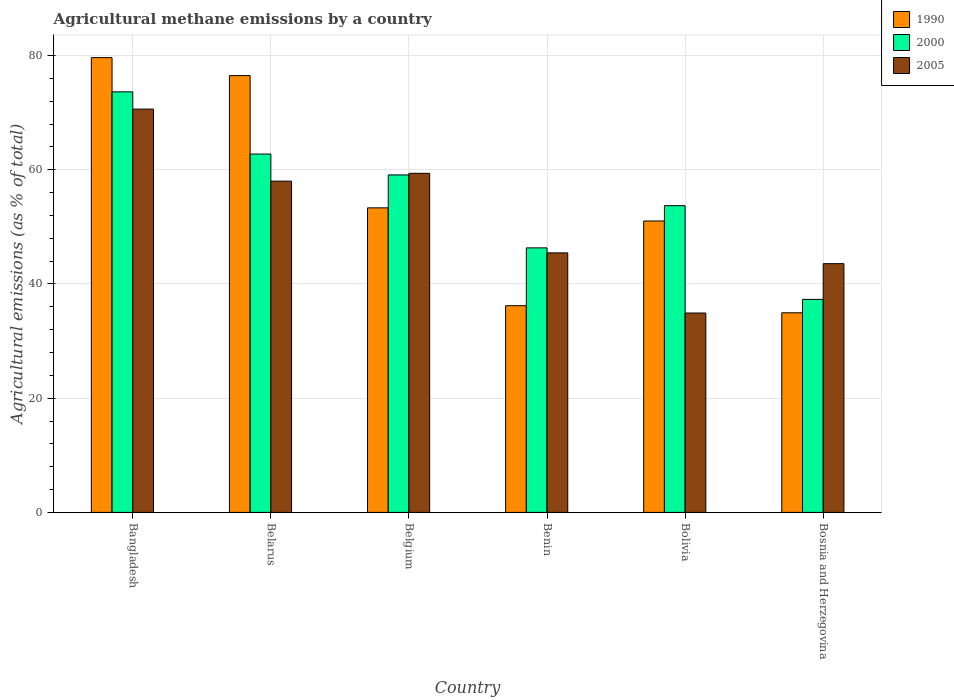How many groups of bars are there?
Keep it short and to the point. 6. How many bars are there on the 6th tick from the right?
Make the answer very short. 3. What is the label of the 2nd group of bars from the left?
Offer a terse response. Belarus. In how many cases, is the number of bars for a given country not equal to the number of legend labels?
Offer a terse response. 0. What is the amount of agricultural methane emitted in 2005 in Bolivia?
Ensure brevity in your answer.  34.92. Across all countries, what is the maximum amount of agricultural methane emitted in 2005?
Your answer should be very brief. 70.62. Across all countries, what is the minimum amount of agricultural methane emitted in 2005?
Your response must be concise. 34.92. What is the total amount of agricultural methane emitted in 1990 in the graph?
Keep it short and to the point. 331.63. What is the difference between the amount of agricultural methane emitted in 1990 in Bolivia and that in Bosnia and Herzegovina?
Ensure brevity in your answer.  16.08. What is the difference between the amount of agricultural methane emitted in 2000 in Bolivia and the amount of agricultural methane emitted in 2005 in Benin?
Offer a very short reply. 8.27. What is the average amount of agricultural methane emitted in 1990 per country?
Provide a succinct answer. 55.27. What is the difference between the amount of agricultural methane emitted of/in 2000 and amount of agricultural methane emitted of/in 1990 in Bangladesh?
Offer a terse response. -6. What is the ratio of the amount of agricultural methane emitted in 2005 in Benin to that in Bosnia and Herzegovina?
Provide a succinct answer. 1.04. Is the amount of agricultural methane emitted in 1990 in Bolivia less than that in Bosnia and Herzegovina?
Keep it short and to the point. No. Is the difference between the amount of agricultural methane emitted in 2000 in Belarus and Benin greater than the difference between the amount of agricultural methane emitted in 1990 in Belarus and Benin?
Offer a terse response. No. What is the difference between the highest and the second highest amount of agricultural methane emitted in 2005?
Provide a succinct answer. -1.37. What is the difference between the highest and the lowest amount of agricultural methane emitted in 1990?
Your answer should be compact. 44.69. Is the sum of the amount of agricultural methane emitted in 2000 in Belarus and Benin greater than the maximum amount of agricultural methane emitted in 1990 across all countries?
Offer a terse response. Yes. What does the 2nd bar from the left in Belarus represents?
Make the answer very short. 2000. Is it the case that in every country, the sum of the amount of agricultural methane emitted in 2005 and amount of agricultural methane emitted in 1990 is greater than the amount of agricultural methane emitted in 2000?
Your answer should be compact. Yes. How many countries are there in the graph?
Ensure brevity in your answer.  6. Does the graph contain grids?
Keep it short and to the point. Yes. Where does the legend appear in the graph?
Keep it short and to the point. Top right. How many legend labels are there?
Ensure brevity in your answer.  3. How are the legend labels stacked?
Ensure brevity in your answer.  Vertical. What is the title of the graph?
Ensure brevity in your answer.  Agricultural methane emissions by a country. What is the label or title of the Y-axis?
Provide a short and direct response. Agricultural emissions (as % of total). What is the Agricultural emissions (as % of total) in 1990 in Bangladesh?
Offer a terse response. 79.64. What is the Agricultural emissions (as % of total) of 2000 in Bangladesh?
Provide a succinct answer. 73.64. What is the Agricultural emissions (as % of total) in 2005 in Bangladesh?
Keep it short and to the point. 70.62. What is the Agricultural emissions (as % of total) of 1990 in Belarus?
Offer a terse response. 76.49. What is the Agricultural emissions (as % of total) in 2000 in Belarus?
Ensure brevity in your answer.  62.75. What is the Agricultural emissions (as % of total) in 2005 in Belarus?
Make the answer very short. 58.01. What is the Agricultural emissions (as % of total) in 1990 in Belgium?
Your answer should be very brief. 53.33. What is the Agricultural emissions (as % of total) in 2000 in Belgium?
Offer a very short reply. 59.1. What is the Agricultural emissions (as % of total) in 2005 in Belgium?
Your answer should be compact. 59.37. What is the Agricultural emissions (as % of total) in 1990 in Benin?
Provide a short and direct response. 36.19. What is the Agricultural emissions (as % of total) of 2000 in Benin?
Provide a short and direct response. 46.32. What is the Agricultural emissions (as % of total) of 2005 in Benin?
Make the answer very short. 45.44. What is the Agricultural emissions (as % of total) in 1990 in Bolivia?
Ensure brevity in your answer.  51.03. What is the Agricultural emissions (as % of total) of 2000 in Bolivia?
Give a very brief answer. 53.71. What is the Agricultural emissions (as % of total) of 2005 in Bolivia?
Give a very brief answer. 34.92. What is the Agricultural emissions (as % of total) of 1990 in Bosnia and Herzegovina?
Offer a very short reply. 34.95. What is the Agricultural emissions (as % of total) of 2000 in Bosnia and Herzegovina?
Provide a short and direct response. 37.3. What is the Agricultural emissions (as % of total) of 2005 in Bosnia and Herzegovina?
Provide a succinct answer. 43.56. Across all countries, what is the maximum Agricultural emissions (as % of total) in 1990?
Offer a very short reply. 79.64. Across all countries, what is the maximum Agricultural emissions (as % of total) of 2000?
Provide a succinct answer. 73.64. Across all countries, what is the maximum Agricultural emissions (as % of total) in 2005?
Offer a very short reply. 70.62. Across all countries, what is the minimum Agricultural emissions (as % of total) of 1990?
Provide a succinct answer. 34.95. Across all countries, what is the minimum Agricultural emissions (as % of total) in 2000?
Your answer should be very brief. 37.3. Across all countries, what is the minimum Agricultural emissions (as % of total) in 2005?
Keep it short and to the point. 34.92. What is the total Agricultural emissions (as % of total) in 1990 in the graph?
Make the answer very short. 331.63. What is the total Agricultural emissions (as % of total) of 2000 in the graph?
Give a very brief answer. 332.83. What is the total Agricultural emissions (as % of total) of 2005 in the graph?
Give a very brief answer. 311.92. What is the difference between the Agricultural emissions (as % of total) in 1990 in Bangladesh and that in Belarus?
Make the answer very short. 3.15. What is the difference between the Agricultural emissions (as % of total) in 2000 in Bangladesh and that in Belarus?
Provide a short and direct response. 10.89. What is the difference between the Agricultural emissions (as % of total) in 2005 in Bangladesh and that in Belarus?
Your answer should be compact. 12.62. What is the difference between the Agricultural emissions (as % of total) in 1990 in Bangladesh and that in Belgium?
Your answer should be very brief. 26.31. What is the difference between the Agricultural emissions (as % of total) in 2000 in Bangladesh and that in Belgium?
Your response must be concise. 14.55. What is the difference between the Agricultural emissions (as % of total) in 2005 in Bangladesh and that in Belgium?
Your answer should be very brief. 11.25. What is the difference between the Agricultural emissions (as % of total) of 1990 in Bangladesh and that in Benin?
Give a very brief answer. 43.44. What is the difference between the Agricultural emissions (as % of total) in 2000 in Bangladesh and that in Benin?
Make the answer very short. 27.32. What is the difference between the Agricultural emissions (as % of total) in 2005 in Bangladesh and that in Benin?
Offer a terse response. 25.18. What is the difference between the Agricultural emissions (as % of total) of 1990 in Bangladesh and that in Bolivia?
Provide a succinct answer. 28.61. What is the difference between the Agricultural emissions (as % of total) in 2000 in Bangladesh and that in Bolivia?
Keep it short and to the point. 19.93. What is the difference between the Agricultural emissions (as % of total) in 2005 in Bangladesh and that in Bolivia?
Give a very brief answer. 35.71. What is the difference between the Agricultural emissions (as % of total) in 1990 in Bangladesh and that in Bosnia and Herzegovina?
Keep it short and to the point. 44.69. What is the difference between the Agricultural emissions (as % of total) of 2000 in Bangladesh and that in Bosnia and Herzegovina?
Keep it short and to the point. 36.34. What is the difference between the Agricultural emissions (as % of total) in 2005 in Bangladesh and that in Bosnia and Herzegovina?
Make the answer very short. 27.06. What is the difference between the Agricultural emissions (as % of total) in 1990 in Belarus and that in Belgium?
Your answer should be very brief. 23.16. What is the difference between the Agricultural emissions (as % of total) in 2000 in Belarus and that in Belgium?
Give a very brief answer. 3.65. What is the difference between the Agricultural emissions (as % of total) in 2005 in Belarus and that in Belgium?
Offer a very short reply. -1.37. What is the difference between the Agricultural emissions (as % of total) of 1990 in Belarus and that in Benin?
Your answer should be very brief. 40.29. What is the difference between the Agricultural emissions (as % of total) in 2000 in Belarus and that in Benin?
Give a very brief answer. 16.43. What is the difference between the Agricultural emissions (as % of total) in 2005 in Belarus and that in Benin?
Make the answer very short. 12.56. What is the difference between the Agricultural emissions (as % of total) of 1990 in Belarus and that in Bolivia?
Your answer should be compact. 25.46. What is the difference between the Agricultural emissions (as % of total) of 2000 in Belarus and that in Bolivia?
Ensure brevity in your answer.  9.04. What is the difference between the Agricultural emissions (as % of total) of 2005 in Belarus and that in Bolivia?
Give a very brief answer. 23.09. What is the difference between the Agricultural emissions (as % of total) in 1990 in Belarus and that in Bosnia and Herzegovina?
Your answer should be compact. 41.53. What is the difference between the Agricultural emissions (as % of total) of 2000 in Belarus and that in Bosnia and Herzegovina?
Offer a terse response. 25.45. What is the difference between the Agricultural emissions (as % of total) in 2005 in Belarus and that in Bosnia and Herzegovina?
Provide a short and direct response. 14.44. What is the difference between the Agricultural emissions (as % of total) of 1990 in Belgium and that in Benin?
Offer a very short reply. 17.14. What is the difference between the Agricultural emissions (as % of total) of 2000 in Belgium and that in Benin?
Your answer should be compact. 12.77. What is the difference between the Agricultural emissions (as % of total) of 2005 in Belgium and that in Benin?
Your answer should be very brief. 13.93. What is the difference between the Agricultural emissions (as % of total) of 1990 in Belgium and that in Bolivia?
Offer a terse response. 2.3. What is the difference between the Agricultural emissions (as % of total) in 2000 in Belgium and that in Bolivia?
Provide a short and direct response. 5.38. What is the difference between the Agricultural emissions (as % of total) of 2005 in Belgium and that in Bolivia?
Your answer should be very brief. 24.46. What is the difference between the Agricultural emissions (as % of total) of 1990 in Belgium and that in Bosnia and Herzegovina?
Your answer should be very brief. 18.38. What is the difference between the Agricultural emissions (as % of total) of 2000 in Belgium and that in Bosnia and Herzegovina?
Ensure brevity in your answer.  21.79. What is the difference between the Agricultural emissions (as % of total) of 2005 in Belgium and that in Bosnia and Herzegovina?
Offer a very short reply. 15.81. What is the difference between the Agricultural emissions (as % of total) in 1990 in Benin and that in Bolivia?
Keep it short and to the point. -14.83. What is the difference between the Agricultural emissions (as % of total) in 2000 in Benin and that in Bolivia?
Give a very brief answer. -7.39. What is the difference between the Agricultural emissions (as % of total) in 2005 in Benin and that in Bolivia?
Provide a short and direct response. 10.53. What is the difference between the Agricultural emissions (as % of total) in 1990 in Benin and that in Bosnia and Herzegovina?
Offer a very short reply. 1.24. What is the difference between the Agricultural emissions (as % of total) in 2000 in Benin and that in Bosnia and Herzegovina?
Provide a succinct answer. 9.02. What is the difference between the Agricultural emissions (as % of total) in 2005 in Benin and that in Bosnia and Herzegovina?
Ensure brevity in your answer.  1.88. What is the difference between the Agricultural emissions (as % of total) in 1990 in Bolivia and that in Bosnia and Herzegovina?
Your response must be concise. 16.08. What is the difference between the Agricultural emissions (as % of total) in 2000 in Bolivia and that in Bosnia and Herzegovina?
Ensure brevity in your answer.  16.41. What is the difference between the Agricultural emissions (as % of total) of 2005 in Bolivia and that in Bosnia and Herzegovina?
Offer a terse response. -8.64. What is the difference between the Agricultural emissions (as % of total) of 1990 in Bangladesh and the Agricultural emissions (as % of total) of 2000 in Belarus?
Your answer should be compact. 16.89. What is the difference between the Agricultural emissions (as % of total) of 1990 in Bangladesh and the Agricultural emissions (as % of total) of 2005 in Belarus?
Make the answer very short. 21.63. What is the difference between the Agricultural emissions (as % of total) of 2000 in Bangladesh and the Agricultural emissions (as % of total) of 2005 in Belarus?
Your response must be concise. 15.64. What is the difference between the Agricultural emissions (as % of total) of 1990 in Bangladesh and the Agricultural emissions (as % of total) of 2000 in Belgium?
Your answer should be compact. 20.54. What is the difference between the Agricultural emissions (as % of total) in 1990 in Bangladesh and the Agricultural emissions (as % of total) in 2005 in Belgium?
Provide a succinct answer. 20.27. What is the difference between the Agricultural emissions (as % of total) in 2000 in Bangladesh and the Agricultural emissions (as % of total) in 2005 in Belgium?
Your answer should be compact. 14.27. What is the difference between the Agricultural emissions (as % of total) in 1990 in Bangladesh and the Agricultural emissions (as % of total) in 2000 in Benin?
Make the answer very short. 33.32. What is the difference between the Agricultural emissions (as % of total) in 1990 in Bangladesh and the Agricultural emissions (as % of total) in 2005 in Benin?
Your answer should be very brief. 34.2. What is the difference between the Agricultural emissions (as % of total) of 2000 in Bangladesh and the Agricultural emissions (as % of total) of 2005 in Benin?
Provide a short and direct response. 28.2. What is the difference between the Agricultural emissions (as % of total) in 1990 in Bangladesh and the Agricultural emissions (as % of total) in 2000 in Bolivia?
Provide a short and direct response. 25.92. What is the difference between the Agricultural emissions (as % of total) of 1990 in Bangladesh and the Agricultural emissions (as % of total) of 2005 in Bolivia?
Your answer should be compact. 44.72. What is the difference between the Agricultural emissions (as % of total) in 2000 in Bangladesh and the Agricultural emissions (as % of total) in 2005 in Bolivia?
Provide a succinct answer. 38.73. What is the difference between the Agricultural emissions (as % of total) in 1990 in Bangladesh and the Agricultural emissions (as % of total) in 2000 in Bosnia and Herzegovina?
Your answer should be very brief. 42.34. What is the difference between the Agricultural emissions (as % of total) in 1990 in Bangladesh and the Agricultural emissions (as % of total) in 2005 in Bosnia and Herzegovina?
Your answer should be very brief. 36.08. What is the difference between the Agricultural emissions (as % of total) of 2000 in Bangladesh and the Agricultural emissions (as % of total) of 2005 in Bosnia and Herzegovina?
Offer a very short reply. 30.08. What is the difference between the Agricultural emissions (as % of total) of 1990 in Belarus and the Agricultural emissions (as % of total) of 2000 in Belgium?
Your answer should be very brief. 17.39. What is the difference between the Agricultural emissions (as % of total) in 1990 in Belarus and the Agricultural emissions (as % of total) in 2005 in Belgium?
Give a very brief answer. 17.11. What is the difference between the Agricultural emissions (as % of total) of 2000 in Belarus and the Agricultural emissions (as % of total) of 2005 in Belgium?
Offer a terse response. 3.38. What is the difference between the Agricultural emissions (as % of total) of 1990 in Belarus and the Agricultural emissions (as % of total) of 2000 in Benin?
Your answer should be very brief. 30.16. What is the difference between the Agricultural emissions (as % of total) in 1990 in Belarus and the Agricultural emissions (as % of total) in 2005 in Benin?
Your answer should be compact. 31.04. What is the difference between the Agricultural emissions (as % of total) of 2000 in Belarus and the Agricultural emissions (as % of total) of 2005 in Benin?
Give a very brief answer. 17.31. What is the difference between the Agricultural emissions (as % of total) of 1990 in Belarus and the Agricultural emissions (as % of total) of 2000 in Bolivia?
Offer a very short reply. 22.77. What is the difference between the Agricultural emissions (as % of total) of 1990 in Belarus and the Agricultural emissions (as % of total) of 2005 in Bolivia?
Offer a terse response. 41.57. What is the difference between the Agricultural emissions (as % of total) of 2000 in Belarus and the Agricultural emissions (as % of total) of 2005 in Bolivia?
Your answer should be very brief. 27.83. What is the difference between the Agricultural emissions (as % of total) of 1990 in Belarus and the Agricultural emissions (as % of total) of 2000 in Bosnia and Herzegovina?
Offer a terse response. 39.19. What is the difference between the Agricultural emissions (as % of total) in 1990 in Belarus and the Agricultural emissions (as % of total) in 2005 in Bosnia and Herzegovina?
Your response must be concise. 32.93. What is the difference between the Agricultural emissions (as % of total) in 2000 in Belarus and the Agricultural emissions (as % of total) in 2005 in Bosnia and Herzegovina?
Your response must be concise. 19.19. What is the difference between the Agricultural emissions (as % of total) in 1990 in Belgium and the Agricultural emissions (as % of total) in 2000 in Benin?
Ensure brevity in your answer.  7.01. What is the difference between the Agricultural emissions (as % of total) of 1990 in Belgium and the Agricultural emissions (as % of total) of 2005 in Benin?
Your response must be concise. 7.89. What is the difference between the Agricultural emissions (as % of total) in 2000 in Belgium and the Agricultural emissions (as % of total) in 2005 in Benin?
Your answer should be very brief. 13.65. What is the difference between the Agricultural emissions (as % of total) in 1990 in Belgium and the Agricultural emissions (as % of total) in 2000 in Bolivia?
Give a very brief answer. -0.38. What is the difference between the Agricultural emissions (as % of total) in 1990 in Belgium and the Agricultural emissions (as % of total) in 2005 in Bolivia?
Offer a very short reply. 18.41. What is the difference between the Agricultural emissions (as % of total) of 2000 in Belgium and the Agricultural emissions (as % of total) of 2005 in Bolivia?
Offer a terse response. 24.18. What is the difference between the Agricultural emissions (as % of total) of 1990 in Belgium and the Agricultural emissions (as % of total) of 2000 in Bosnia and Herzegovina?
Ensure brevity in your answer.  16.03. What is the difference between the Agricultural emissions (as % of total) of 1990 in Belgium and the Agricultural emissions (as % of total) of 2005 in Bosnia and Herzegovina?
Provide a succinct answer. 9.77. What is the difference between the Agricultural emissions (as % of total) in 2000 in Belgium and the Agricultural emissions (as % of total) in 2005 in Bosnia and Herzegovina?
Provide a succinct answer. 15.54. What is the difference between the Agricultural emissions (as % of total) of 1990 in Benin and the Agricultural emissions (as % of total) of 2000 in Bolivia?
Provide a short and direct response. -17.52. What is the difference between the Agricultural emissions (as % of total) of 1990 in Benin and the Agricultural emissions (as % of total) of 2005 in Bolivia?
Provide a short and direct response. 1.28. What is the difference between the Agricultural emissions (as % of total) of 2000 in Benin and the Agricultural emissions (as % of total) of 2005 in Bolivia?
Keep it short and to the point. 11.41. What is the difference between the Agricultural emissions (as % of total) in 1990 in Benin and the Agricultural emissions (as % of total) in 2000 in Bosnia and Herzegovina?
Offer a terse response. -1.11. What is the difference between the Agricultural emissions (as % of total) in 1990 in Benin and the Agricultural emissions (as % of total) in 2005 in Bosnia and Herzegovina?
Offer a very short reply. -7.37. What is the difference between the Agricultural emissions (as % of total) of 2000 in Benin and the Agricultural emissions (as % of total) of 2005 in Bosnia and Herzegovina?
Offer a very short reply. 2.76. What is the difference between the Agricultural emissions (as % of total) in 1990 in Bolivia and the Agricultural emissions (as % of total) in 2000 in Bosnia and Herzegovina?
Your answer should be very brief. 13.73. What is the difference between the Agricultural emissions (as % of total) of 1990 in Bolivia and the Agricultural emissions (as % of total) of 2005 in Bosnia and Herzegovina?
Make the answer very short. 7.47. What is the difference between the Agricultural emissions (as % of total) in 2000 in Bolivia and the Agricultural emissions (as % of total) in 2005 in Bosnia and Herzegovina?
Ensure brevity in your answer.  10.15. What is the average Agricultural emissions (as % of total) in 1990 per country?
Your answer should be compact. 55.27. What is the average Agricultural emissions (as % of total) in 2000 per country?
Your answer should be very brief. 55.47. What is the average Agricultural emissions (as % of total) in 2005 per country?
Ensure brevity in your answer.  51.99. What is the difference between the Agricultural emissions (as % of total) in 1990 and Agricultural emissions (as % of total) in 2000 in Bangladesh?
Your response must be concise. 6. What is the difference between the Agricultural emissions (as % of total) in 1990 and Agricultural emissions (as % of total) in 2005 in Bangladesh?
Keep it short and to the point. 9.02. What is the difference between the Agricultural emissions (as % of total) in 2000 and Agricultural emissions (as % of total) in 2005 in Bangladesh?
Offer a terse response. 3.02. What is the difference between the Agricultural emissions (as % of total) in 1990 and Agricultural emissions (as % of total) in 2000 in Belarus?
Your response must be concise. 13.74. What is the difference between the Agricultural emissions (as % of total) in 1990 and Agricultural emissions (as % of total) in 2005 in Belarus?
Keep it short and to the point. 18.48. What is the difference between the Agricultural emissions (as % of total) of 2000 and Agricultural emissions (as % of total) of 2005 in Belarus?
Your answer should be compact. 4.74. What is the difference between the Agricultural emissions (as % of total) of 1990 and Agricultural emissions (as % of total) of 2000 in Belgium?
Keep it short and to the point. -5.77. What is the difference between the Agricultural emissions (as % of total) in 1990 and Agricultural emissions (as % of total) in 2005 in Belgium?
Provide a short and direct response. -6.04. What is the difference between the Agricultural emissions (as % of total) in 2000 and Agricultural emissions (as % of total) in 2005 in Belgium?
Your response must be concise. -0.28. What is the difference between the Agricultural emissions (as % of total) in 1990 and Agricultural emissions (as % of total) in 2000 in Benin?
Offer a terse response. -10.13. What is the difference between the Agricultural emissions (as % of total) of 1990 and Agricultural emissions (as % of total) of 2005 in Benin?
Offer a very short reply. -9.25. What is the difference between the Agricultural emissions (as % of total) in 2000 and Agricultural emissions (as % of total) in 2005 in Benin?
Your answer should be very brief. 0.88. What is the difference between the Agricultural emissions (as % of total) in 1990 and Agricultural emissions (as % of total) in 2000 in Bolivia?
Provide a short and direct response. -2.69. What is the difference between the Agricultural emissions (as % of total) in 1990 and Agricultural emissions (as % of total) in 2005 in Bolivia?
Provide a short and direct response. 16.11. What is the difference between the Agricultural emissions (as % of total) of 2000 and Agricultural emissions (as % of total) of 2005 in Bolivia?
Your answer should be very brief. 18.8. What is the difference between the Agricultural emissions (as % of total) in 1990 and Agricultural emissions (as % of total) in 2000 in Bosnia and Herzegovina?
Keep it short and to the point. -2.35. What is the difference between the Agricultural emissions (as % of total) of 1990 and Agricultural emissions (as % of total) of 2005 in Bosnia and Herzegovina?
Your answer should be compact. -8.61. What is the difference between the Agricultural emissions (as % of total) in 2000 and Agricultural emissions (as % of total) in 2005 in Bosnia and Herzegovina?
Your answer should be compact. -6.26. What is the ratio of the Agricultural emissions (as % of total) in 1990 in Bangladesh to that in Belarus?
Offer a terse response. 1.04. What is the ratio of the Agricultural emissions (as % of total) in 2000 in Bangladesh to that in Belarus?
Offer a terse response. 1.17. What is the ratio of the Agricultural emissions (as % of total) of 2005 in Bangladesh to that in Belarus?
Your answer should be very brief. 1.22. What is the ratio of the Agricultural emissions (as % of total) of 1990 in Bangladesh to that in Belgium?
Keep it short and to the point. 1.49. What is the ratio of the Agricultural emissions (as % of total) of 2000 in Bangladesh to that in Belgium?
Make the answer very short. 1.25. What is the ratio of the Agricultural emissions (as % of total) in 2005 in Bangladesh to that in Belgium?
Make the answer very short. 1.19. What is the ratio of the Agricultural emissions (as % of total) of 1990 in Bangladesh to that in Benin?
Provide a succinct answer. 2.2. What is the ratio of the Agricultural emissions (as % of total) of 2000 in Bangladesh to that in Benin?
Provide a short and direct response. 1.59. What is the ratio of the Agricultural emissions (as % of total) in 2005 in Bangladesh to that in Benin?
Give a very brief answer. 1.55. What is the ratio of the Agricultural emissions (as % of total) in 1990 in Bangladesh to that in Bolivia?
Your answer should be very brief. 1.56. What is the ratio of the Agricultural emissions (as % of total) of 2000 in Bangladesh to that in Bolivia?
Provide a succinct answer. 1.37. What is the ratio of the Agricultural emissions (as % of total) in 2005 in Bangladesh to that in Bolivia?
Provide a succinct answer. 2.02. What is the ratio of the Agricultural emissions (as % of total) in 1990 in Bangladesh to that in Bosnia and Herzegovina?
Offer a very short reply. 2.28. What is the ratio of the Agricultural emissions (as % of total) in 2000 in Bangladesh to that in Bosnia and Herzegovina?
Give a very brief answer. 1.97. What is the ratio of the Agricultural emissions (as % of total) of 2005 in Bangladesh to that in Bosnia and Herzegovina?
Offer a terse response. 1.62. What is the ratio of the Agricultural emissions (as % of total) of 1990 in Belarus to that in Belgium?
Make the answer very short. 1.43. What is the ratio of the Agricultural emissions (as % of total) of 2000 in Belarus to that in Belgium?
Give a very brief answer. 1.06. What is the ratio of the Agricultural emissions (as % of total) in 1990 in Belarus to that in Benin?
Your answer should be compact. 2.11. What is the ratio of the Agricultural emissions (as % of total) of 2000 in Belarus to that in Benin?
Your response must be concise. 1.35. What is the ratio of the Agricultural emissions (as % of total) in 2005 in Belarus to that in Benin?
Provide a succinct answer. 1.28. What is the ratio of the Agricultural emissions (as % of total) of 1990 in Belarus to that in Bolivia?
Offer a very short reply. 1.5. What is the ratio of the Agricultural emissions (as % of total) of 2000 in Belarus to that in Bolivia?
Give a very brief answer. 1.17. What is the ratio of the Agricultural emissions (as % of total) of 2005 in Belarus to that in Bolivia?
Offer a very short reply. 1.66. What is the ratio of the Agricultural emissions (as % of total) of 1990 in Belarus to that in Bosnia and Herzegovina?
Your answer should be compact. 2.19. What is the ratio of the Agricultural emissions (as % of total) in 2000 in Belarus to that in Bosnia and Herzegovina?
Ensure brevity in your answer.  1.68. What is the ratio of the Agricultural emissions (as % of total) in 2005 in Belarus to that in Bosnia and Herzegovina?
Provide a short and direct response. 1.33. What is the ratio of the Agricultural emissions (as % of total) of 1990 in Belgium to that in Benin?
Your response must be concise. 1.47. What is the ratio of the Agricultural emissions (as % of total) of 2000 in Belgium to that in Benin?
Provide a short and direct response. 1.28. What is the ratio of the Agricultural emissions (as % of total) in 2005 in Belgium to that in Benin?
Make the answer very short. 1.31. What is the ratio of the Agricultural emissions (as % of total) of 1990 in Belgium to that in Bolivia?
Make the answer very short. 1.05. What is the ratio of the Agricultural emissions (as % of total) in 2000 in Belgium to that in Bolivia?
Offer a very short reply. 1.1. What is the ratio of the Agricultural emissions (as % of total) in 2005 in Belgium to that in Bolivia?
Your answer should be compact. 1.7. What is the ratio of the Agricultural emissions (as % of total) of 1990 in Belgium to that in Bosnia and Herzegovina?
Offer a very short reply. 1.53. What is the ratio of the Agricultural emissions (as % of total) of 2000 in Belgium to that in Bosnia and Herzegovina?
Keep it short and to the point. 1.58. What is the ratio of the Agricultural emissions (as % of total) in 2005 in Belgium to that in Bosnia and Herzegovina?
Your response must be concise. 1.36. What is the ratio of the Agricultural emissions (as % of total) of 1990 in Benin to that in Bolivia?
Your answer should be very brief. 0.71. What is the ratio of the Agricultural emissions (as % of total) of 2000 in Benin to that in Bolivia?
Offer a very short reply. 0.86. What is the ratio of the Agricultural emissions (as % of total) of 2005 in Benin to that in Bolivia?
Provide a short and direct response. 1.3. What is the ratio of the Agricultural emissions (as % of total) of 1990 in Benin to that in Bosnia and Herzegovina?
Keep it short and to the point. 1.04. What is the ratio of the Agricultural emissions (as % of total) of 2000 in Benin to that in Bosnia and Herzegovina?
Offer a terse response. 1.24. What is the ratio of the Agricultural emissions (as % of total) of 2005 in Benin to that in Bosnia and Herzegovina?
Make the answer very short. 1.04. What is the ratio of the Agricultural emissions (as % of total) of 1990 in Bolivia to that in Bosnia and Herzegovina?
Offer a very short reply. 1.46. What is the ratio of the Agricultural emissions (as % of total) of 2000 in Bolivia to that in Bosnia and Herzegovina?
Provide a succinct answer. 1.44. What is the ratio of the Agricultural emissions (as % of total) of 2005 in Bolivia to that in Bosnia and Herzegovina?
Your answer should be very brief. 0.8. What is the difference between the highest and the second highest Agricultural emissions (as % of total) of 1990?
Provide a succinct answer. 3.15. What is the difference between the highest and the second highest Agricultural emissions (as % of total) of 2000?
Your response must be concise. 10.89. What is the difference between the highest and the second highest Agricultural emissions (as % of total) of 2005?
Make the answer very short. 11.25. What is the difference between the highest and the lowest Agricultural emissions (as % of total) in 1990?
Ensure brevity in your answer.  44.69. What is the difference between the highest and the lowest Agricultural emissions (as % of total) of 2000?
Provide a short and direct response. 36.34. What is the difference between the highest and the lowest Agricultural emissions (as % of total) in 2005?
Offer a very short reply. 35.71. 